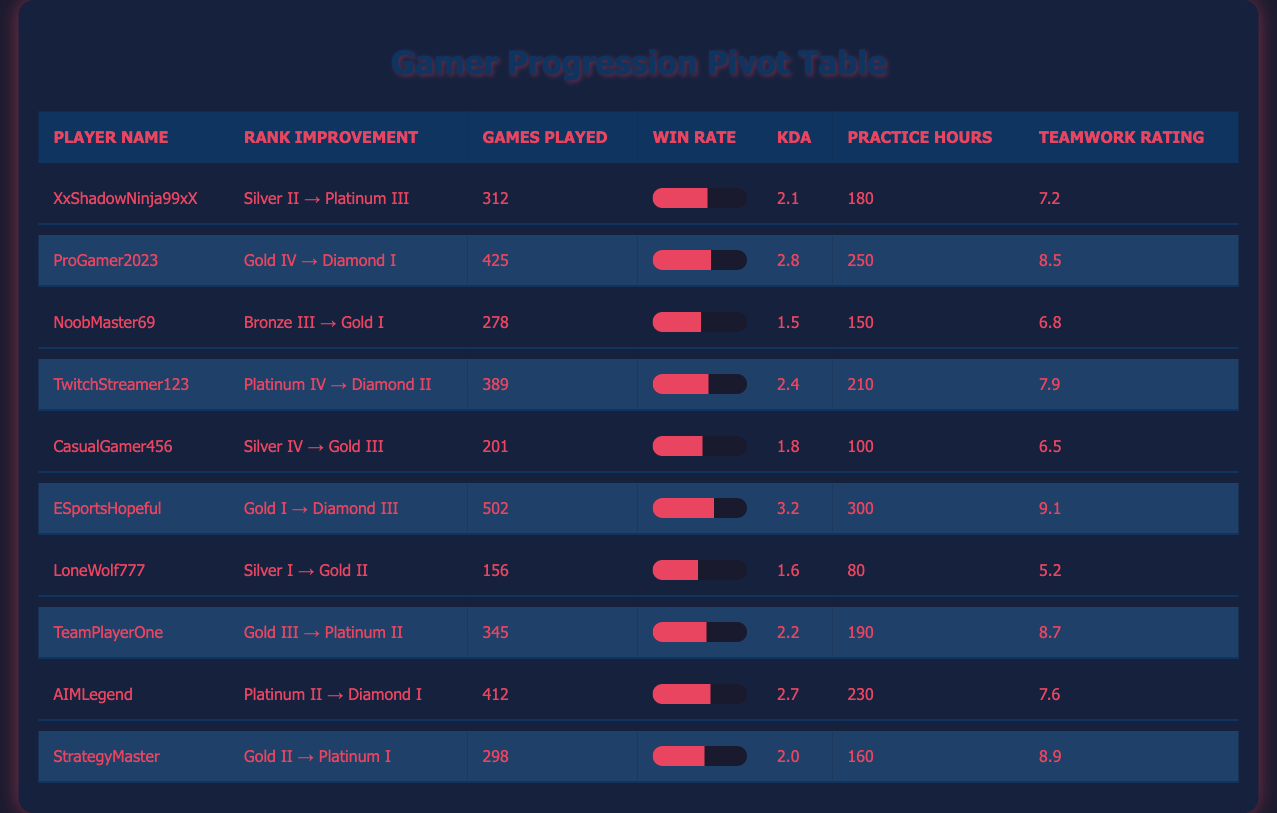What is the final rank of ProGamer2023? ProGamer2023's final rank is listed in the table, specifically in the column labeled "Final Rank." According to the table, their final rank is Diamond I.
Answer: Diamond I How many games did ESportsHopeful play during the season? The number of games played by ESportsHopeful can be found in the column titled "Games Played." The table indicates that they played 502 games.
Answer: 502 Which player has the highest win rate? To determine the player with the highest win rate, I will compare the win rates listed in the "Win Rate" column. The highest value in that column is 0.65, corresponding to ESportsHopeful.
Answer: ESportsHopeful What is the average KDA of all players in the table? I will sum the KDA values of all players (2.1 + 2.8 + 1.5 + 2.4 + 1.8 + 3.2 + 1.6 + 2.2 + 2.7 + 2.0) = 24.3. Since there are 10 players, the average KDA is 24.3 / 10 = 2.43.
Answer: 2.43 Did any player start in Bronze and end in Gold? I need to check the "Initial Rank" and "Final Rank" columns for any player ranked Bronze at the start and Gold at the end. The player NoobMaster69 meets the criteria, having started at Bronze III and finished at Gold I.
Answer: Yes What is the difference in practice hours between the player with the most and the least practice hours? I will identify the maximum and minimum practice hours from the "Practice Hours" column. The highest is 502 hours (ESportsHopeful) and the lowest is 80 hours (LoneWolf777). The difference is 502 - 80 = 422 hours.
Answer: 422 How many players improved their rank to Diamond? I will review the "Final Rank" column to count how many players reached Diamond. The players who achieved Diamond are ProGamer2023, ESportsHopeful, AIMLegend, and TwitchStreamer123, totaling 4 players.
Answer: 4 Which player's teamwork rating is above 8.0? I will look through the "Teamwork Rating" column to find players who received a rating higher than 8.0. The players are ProGamer2023 (8.5), ESportsHopeful (9.1), TeamPlayerOne (8.7), and StrategyMaster (8.9).
Answer: Yes What is the average win rate for the players who started in Gold? The players who started in Gold are ProGamer2023, ESportsHopeful, TeamPlayerOne, AIMLegend, and StrategyMaster. Their win rates are 0.62, 0.65, 0.57, 0.61, and 0.55, respectively. The average is calculated as (0.62 + 0.65 + 0.57 + 0.61 + 0.55) / 5 = 0.600.
Answer: 0.600 